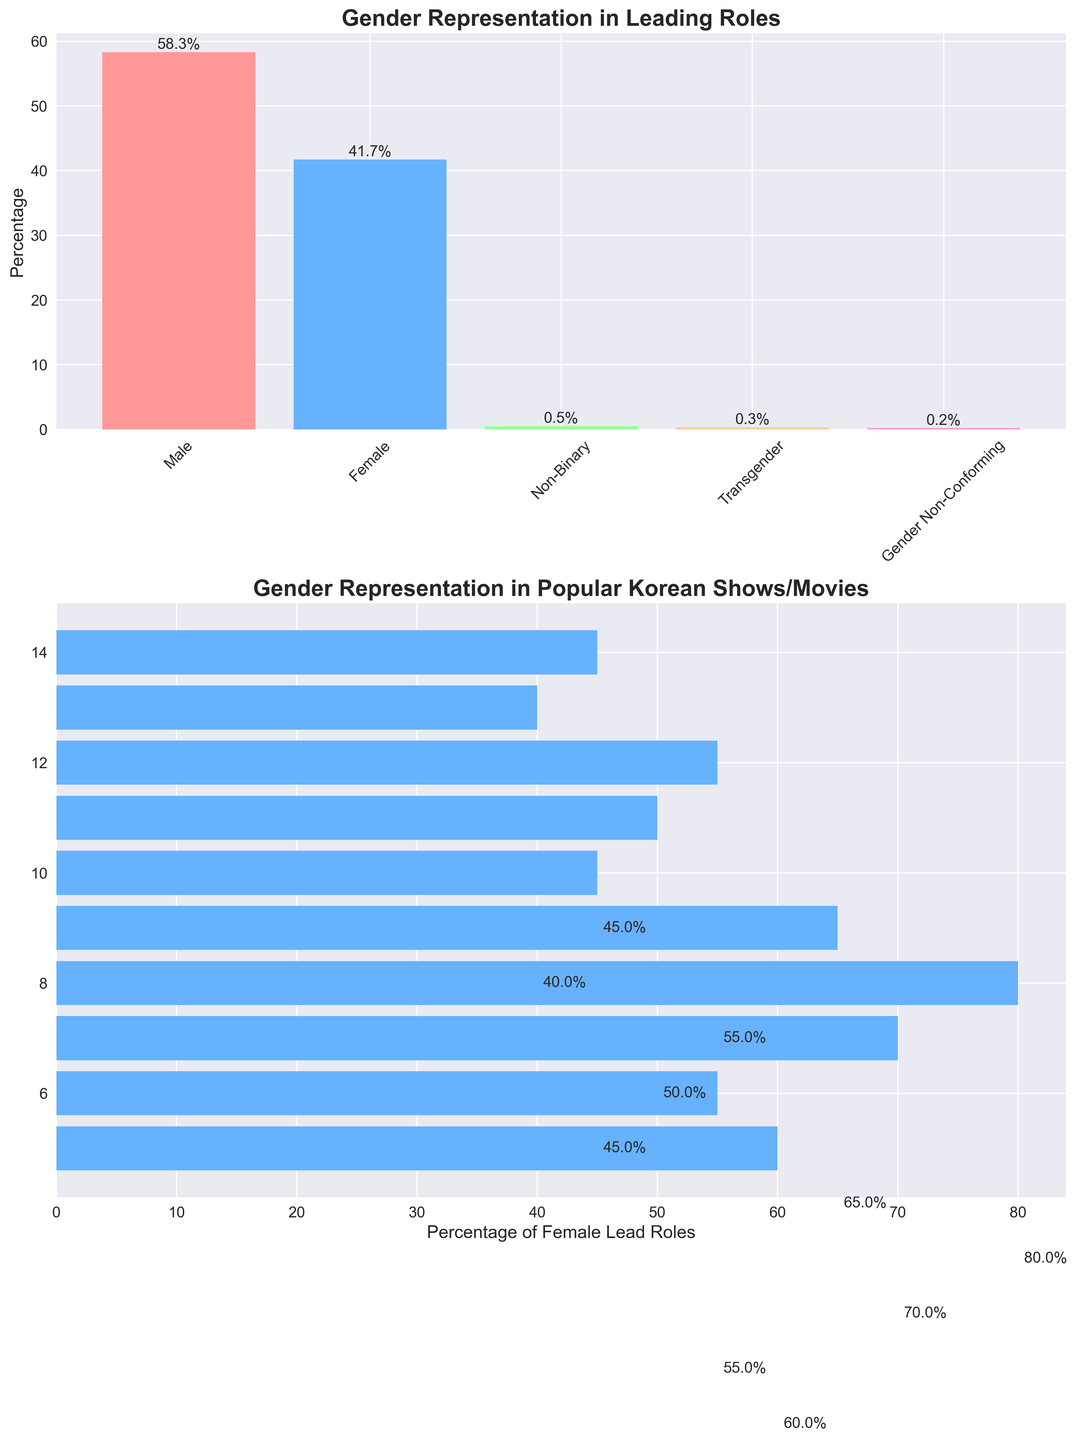Which gender has the highest representation in leading roles? Observing the first subplot, we see that the bar representing Male has the highest percentage at 58.3%.
Answer: Male Which TV show or movie has the lowest percentage of female lead roles? Looking at the second subplot, "Train to Busan" has the lowest percentage at 20%, as indicated by the length of the bar.
Answer: "Train to Busan" What is the total percentage of leading roles represented by Non-Binary, Transgender, and Gender Non-Conforming combined? Add the percentages: 0.5% (Non-Binary) + 0.3% (Transgender) + 0.2% (Gender Non-Conforming). The total is 1%.
Answer: 1% Compare the percentage of female lead roles between "Crash Landing on You" and "Goblin". Which has a higher percentage and by how much? "Crash Landing on You" has 60% while "Goblin" has 40%. The difference is 60% - 40% = 20%.
Answer: "Crash Landing on You" by 20% Is the female lead role percentage for "Squid Game" greater than for "Reply 1988"? "Squid Game" has 45% female lead roles while "Reply 1988" also has 45%. Since 45% is equal to 45%, the percentages are the same.
Answer: No Which gender has the lowest representation in leading roles? Observing the first subplot, Gender Non-Conforming has the lowest percentage at 0.2%.
Answer: Gender Non-Conforming What is the average percentage of female lead roles across all the TV shows and movies listed? Summing the percentages and dividing by the number of shows/movies: (60 + 55 + 70 + 80 + 65 + 45 + 50 + 55 + 40 + 45) / 10 = 56.5%.
Answer: 56.5% By how much does the percentage of female lead roles in "Parasite" exceed that in "Descendants of the Sun"? "Parasite" has 70% and "Descendants of the Sun" has 55%, so the excess is 70% - 55% = 15%.
Answer: 15% What is the percentage difference between Male and Female representation in leading roles? From the first subplot, Male has 58.3% and Female has 41.7%. The difference is 58.3% - 41.7% = 16.6%.
Answer: 16.6% Which TV show or movie has the highest representation of female lead roles? Observing the second subplot, "Train to Busan" has the highest representation at 80%.
Answer: "Train to Busan" 